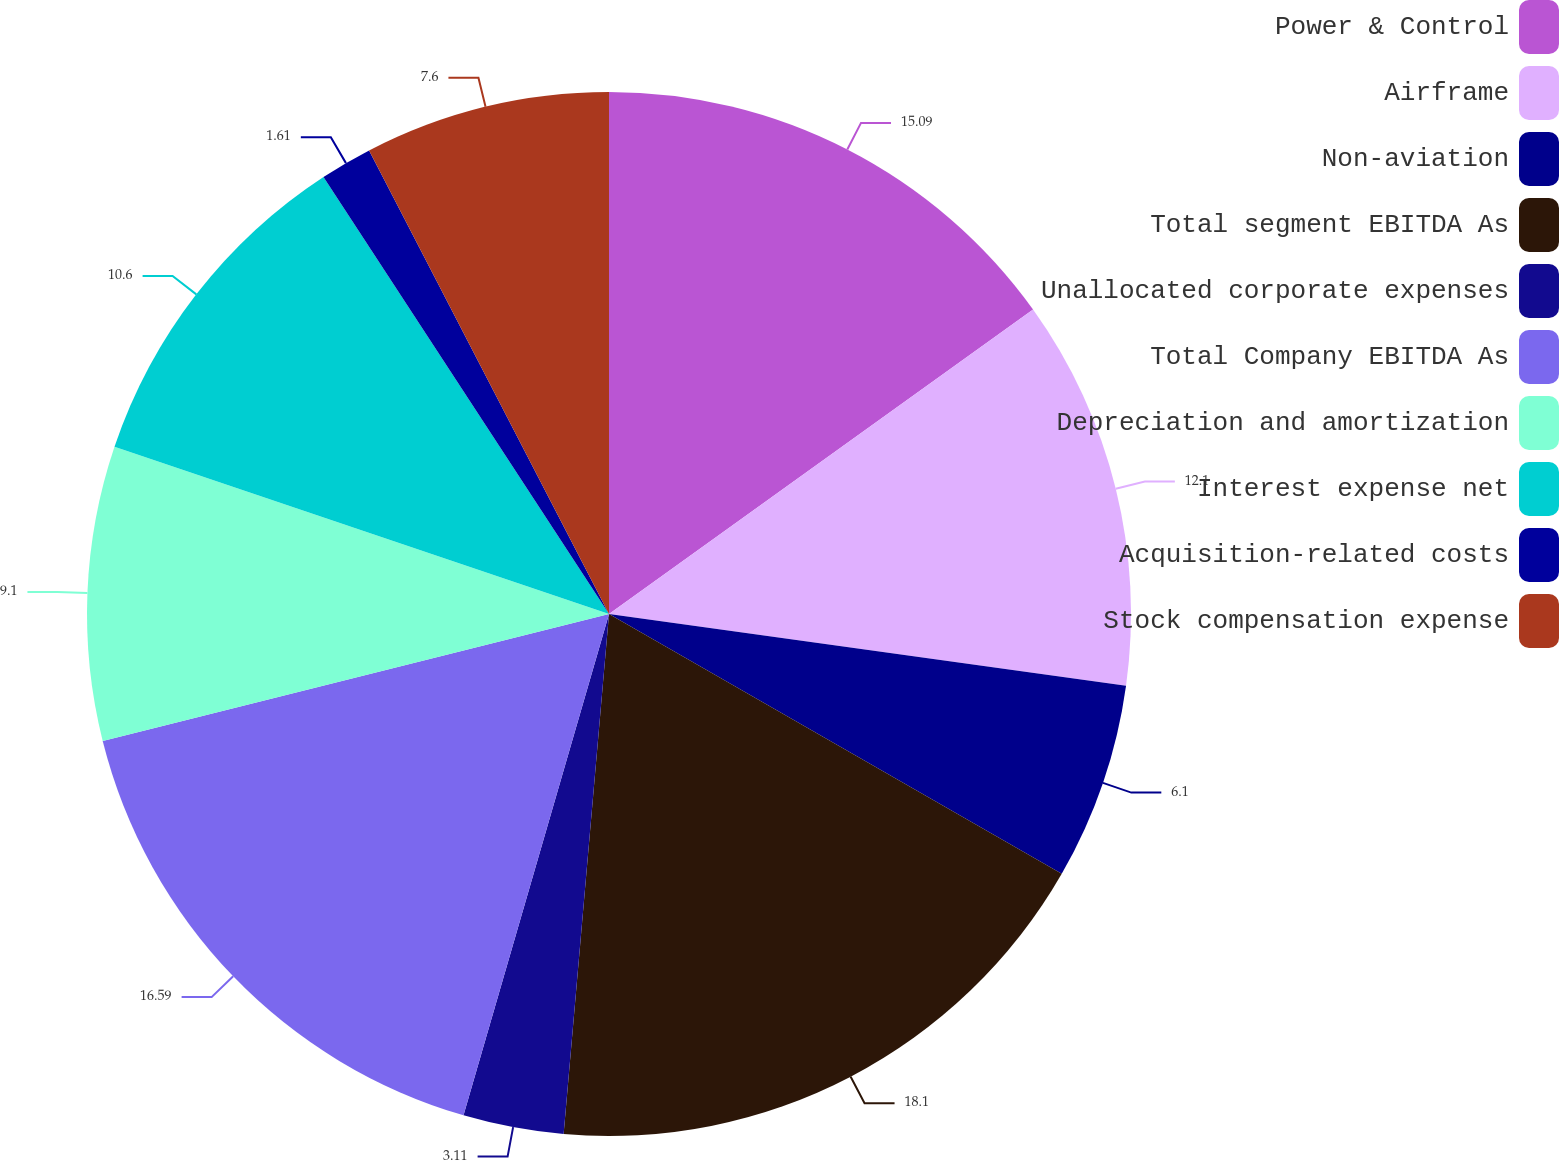Convert chart. <chart><loc_0><loc_0><loc_500><loc_500><pie_chart><fcel>Power & Control<fcel>Airframe<fcel>Non-aviation<fcel>Total segment EBITDA As<fcel>Unallocated corporate expenses<fcel>Total Company EBITDA As<fcel>Depreciation and amortization<fcel>Interest expense net<fcel>Acquisition-related costs<fcel>Stock compensation expense<nl><fcel>15.09%<fcel>12.1%<fcel>6.1%<fcel>18.09%<fcel>3.11%<fcel>16.59%<fcel>9.1%<fcel>10.6%<fcel>1.61%<fcel>7.6%<nl></chart> 